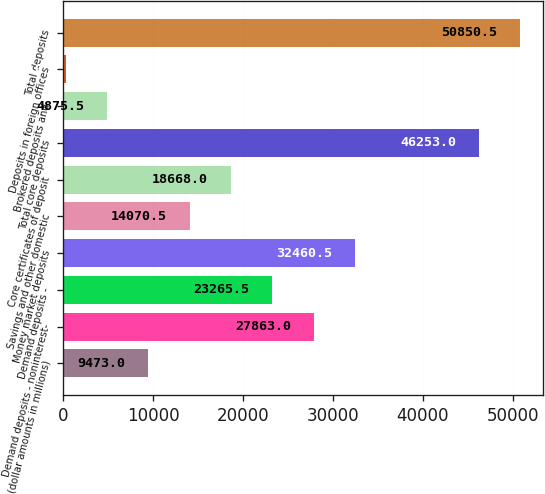<chart> <loc_0><loc_0><loc_500><loc_500><bar_chart><fcel>(dollar amounts in millions)<fcel>Demand deposits - noninterest-<fcel>Demand deposits -<fcel>Money market deposits<fcel>Savings and other domestic<fcel>Core certificates of deposit<fcel>Total core deposits<fcel>Brokered deposits and<fcel>Deposits in foreign offices<fcel>Total deposits<nl><fcel>9473<fcel>27863<fcel>23265.5<fcel>32460.5<fcel>14070.5<fcel>18668<fcel>46253<fcel>4875.5<fcel>278<fcel>50850.5<nl></chart> 